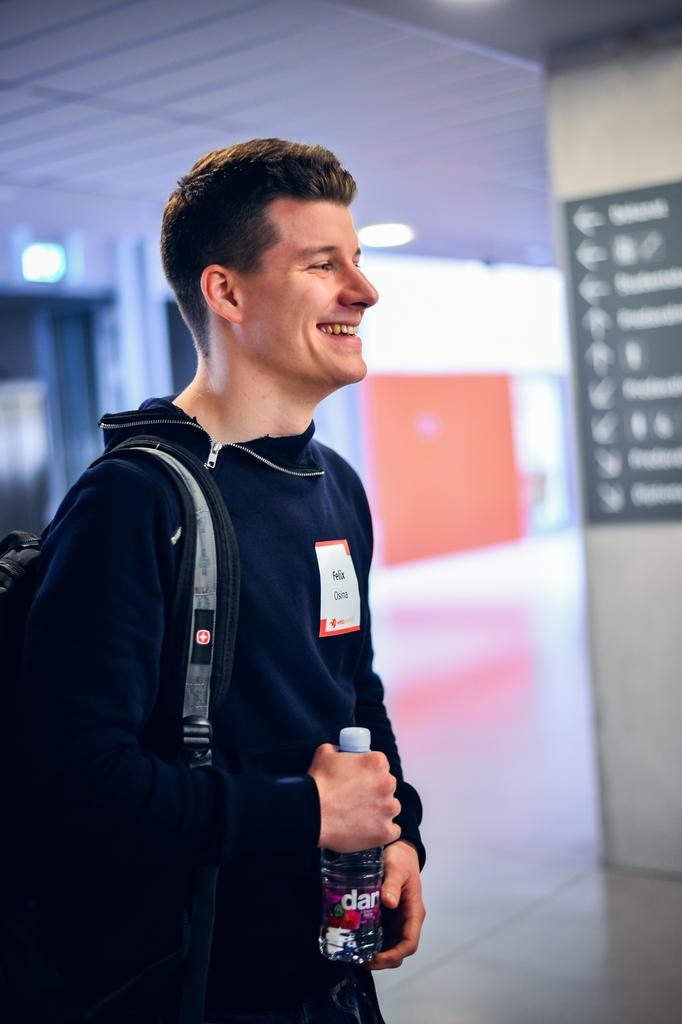Who is present in the image? There is a man in the image. What is the man wearing? The man is wearing a backpack. What is the man holding? The man is holding a bottle. What is the man's facial expression? The man is smiling. Can you describe the background of the image? The background of the image is blurred. What type of surface is visible in the image? There is a floor visible in the image. What type of structure is visible in the image? There is a wall visible in the image. What is hanging on the wall in the image? There is a poster in the image. What type of illumination is visible in the image? There are lights visible in the image. How is the division of labor being managed in the image? There is no indication of labor or division of labor in the image; it features a man wearing a backpack, holding a bottle, and smiling. 